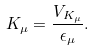<formula> <loc_0><loc_0><loc_500><loc_500>K _ { \mu } = \frac { V _ { K _ { \mu } } } { \epsilon _ { \mu } } .</formula> 